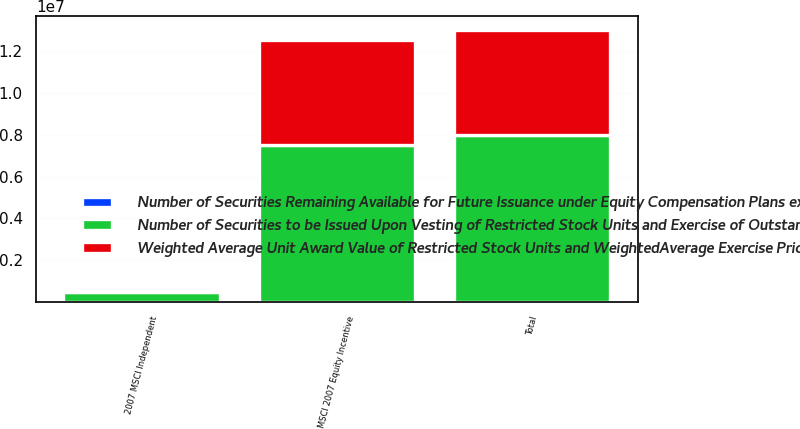<chart> <loc_0><loc_0><loc_500><loc_500><stacked_bar_chart><ecel><fcel>2007 MSCI Independent<fcel>MSCI 2007 Equity Incentive<fcel>Total<nl><fcel>Weighted Average Unit Award Value of Restricted Stock Units and WeightedAverage Exercise Price of Outstanding Options b<fcel>5554<fcel>5.01641e+06<fcel>5.02197e+06<nl><fcel>Number of Securities Remaining Available for Future Issuance under Equity Compensation Plans excluding securities reflected in column a c<fcel>18<fcel>18<fcel>18<nl><fcel>Number of Securities to be Issued Upon Vesting of Restricted Stock Units and Exercise of Outstanding Options a<fcel>483058<fcel>7.48359e+06<fcel>7.96664e+06<nl></chart> 